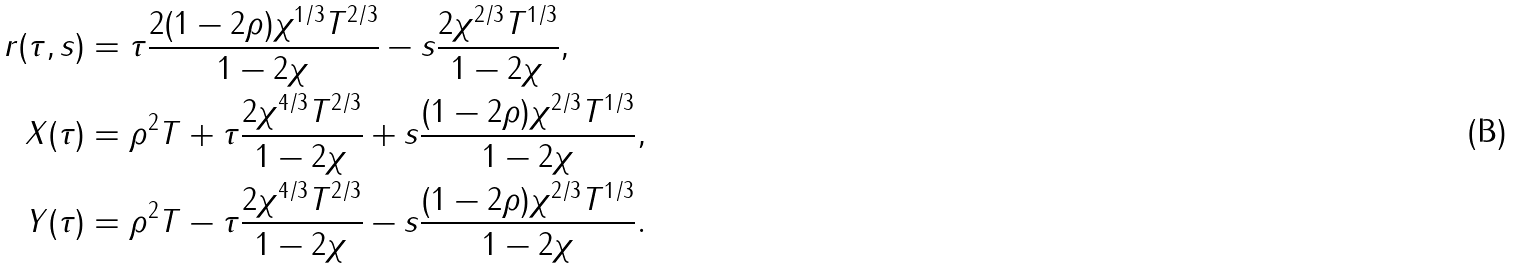Convert formula to latex. <formula><loc_0><loc_0><loc_500><loc_500>r ( \tau , s ) & = \tau \frac { 2 ( 1 - 2 \rho ) \chi ^ { 1 / 3 } T ^ { 2 / 3 } } { 1 - 2 \chi } - s \frac { 2 \chi ^ { 2 / 3 } T ^ { 1 / 3 } } { 1 - 2 \chi } , \\ X ( \tau ) & = \rho ^ { 2 } T + \tau \frac { 2 \chi ^ { 4 / 3 } T ^ { 2 / 3 } } { 1 - 2 \chi } + s \frac { ( 1 - 2 \rho ) \chi ^ { 2 / 3 } T ^ { 1 / 3 } } { 1 - 2 \chi } , \\ Y ( \tau ) & = \rho ^ { 2 } T - \tau \frac { 2 \chi ^ { 4 / 3 } T ^ { 2 / 3 } } { 1 - 2 \chi } - s \frac { ( 1 - 2 \rho ) \chi ^ { 2 / 3 } T ^ { 1 / 3 } } { 1 - 2 \chi } .</formula> 